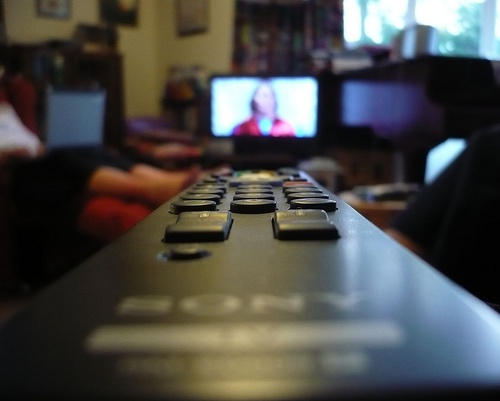Describe the objects in this image and their specific colors. I can see remote in black, gray, darkgreen, and tan tones, people in black, maroon, brown, and darkgray tones, tv in black, white, lightblue, and navy tones, and people in black, lavender, lightblue, and violet tones in this image. 